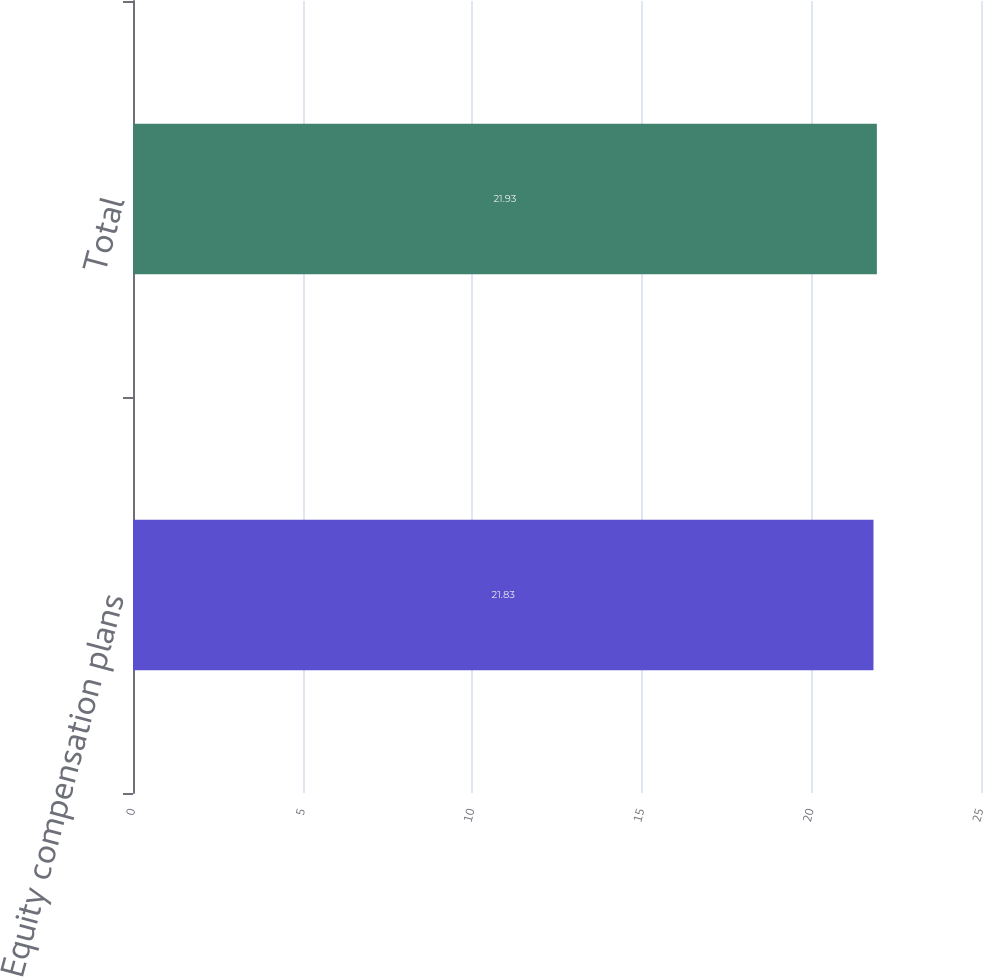Convert chart. <chart><loc_0><loc_0><loc_500><loc_500><bar_chart><fcel>Equity compensation plans<fcel>Total<nl><fcel>21.83<fcel>21.93<nl></chart> 